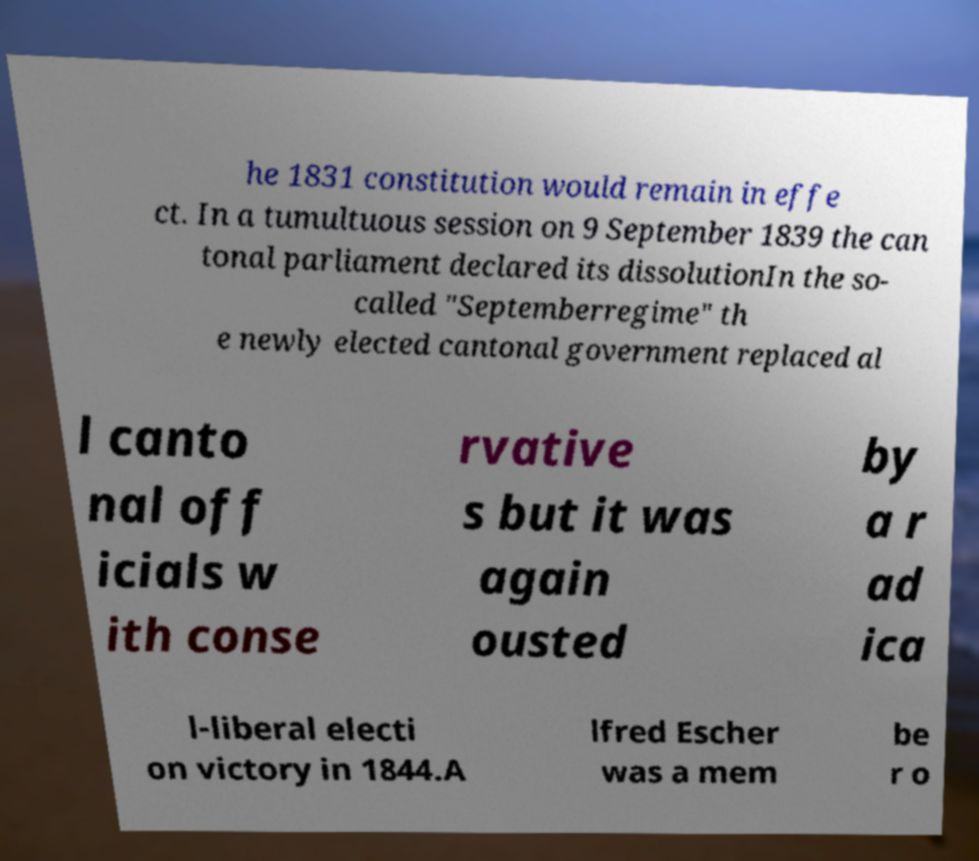Can you accurately transcribe the text from the provided image for me? he 1831 constitution would remain in effe ct. In a tumultuous session on 9 September 1839 the can tonal parliament declared its dissolutionIn the so- called "Septemberregime" th e newly elected cantonal government replaced al l canto nal off icials w ith conse rvative s but it was again ousted by a r ad ica l-liberal electi on victory in 1844.A lfred Escher was a mem be r o 